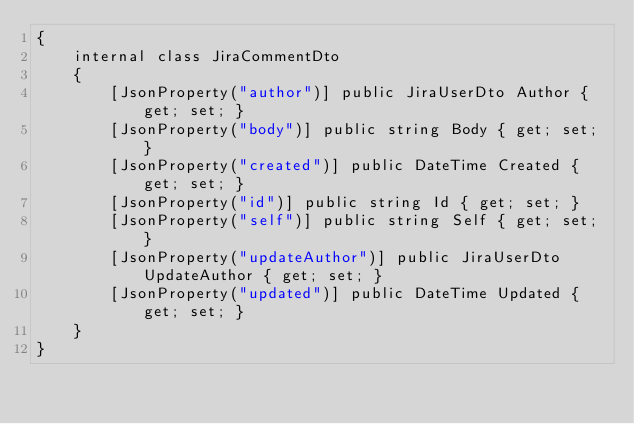<code> <loc_0><loc_0><loc_500><loc_500><_C#_>{
    internal class JiraCommentDto
    {
        [JsonProperty("author")] public JiraUserDto Author { get; set; }
        [JsonProperty("body")] public string Body { get; set; }
        [JsonProperty("created")] public DateTime Created { get; set; }
        [JsonProperty("id")] public string Id { get; set; }
        [JsonProperty("self")] public string Self { get; set; }
        [JsonProperty("updateAuthor")] public JiraUserDto UpdateAuthor { get; set; }
        [JsonProperty("updated")] public DateTime Updated { get; set; }
    }
}</code> 